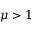<formula> <loc_0><loc_0><loc_500><loc_500>\mu > 1</formula> 